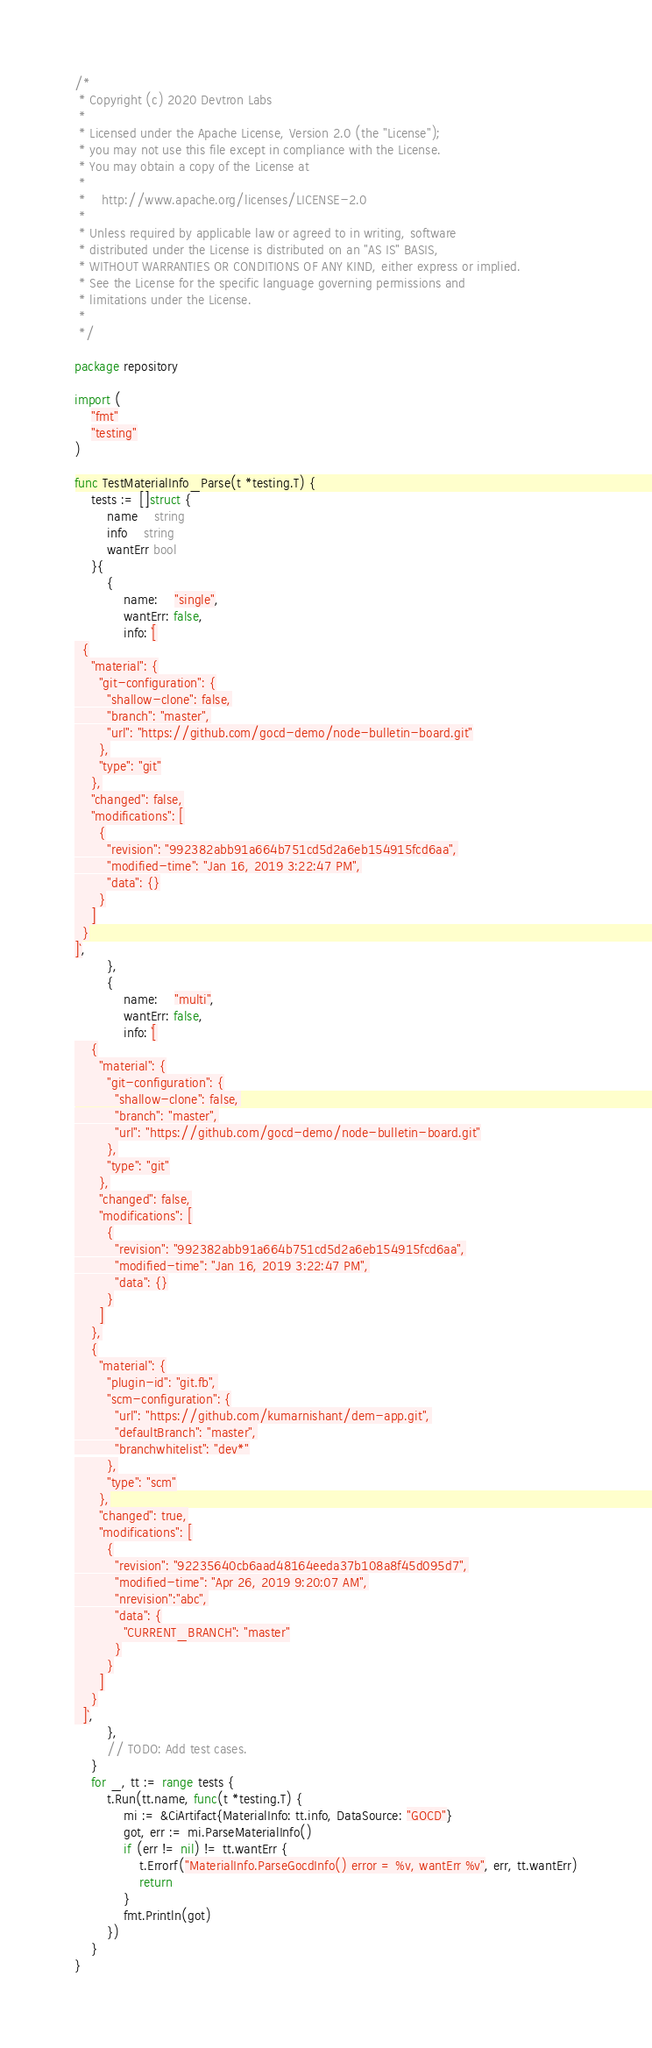<code> <loc_0><loc_0><loc_500><loc_500><_Go_>/*
 * Copyright (c) 2020 Devtron Labs
 *
 * Licensed under the Apache License, Version 2.0 (the "License");
 * you may not use this file except in compliance with the License.
 * You may obtain a copy of the License at
 *
 *    http://www.apache.org/licenses/LICENSE-2.0
 *
 * Unless required by applicable law or agreed to in writing, software
 * distributed under the License is distributed on an "AS IS" BASIS,
 * WITHOUT WARRANTIES OR CONDITIONS OF ANY KIND, either express or implied.
 * See the License for the specific language governing permissions and
 * limitations under the License.
 *
 */

package repository

import (
	"fmt"
	"testing"
)

func TestMaterialInfo_Parse(t *testing.T) {
	tests := []struct {
		name    string
		info    string
		wantErr bool
	}{
		{
			name:    "single",
			wantErr: false,
			info: `[
  {
    "material": {
      "git-configuration": {
        "shallow-clone": false,
        "branch": "master",
        "url": "https://github.com/gocd-demo/node-bulletin-board.git"
      },
      "type": "git"
    },
    "changed": false,
    "modifications": [
      {
        "revision": "992382abb91a664b751cd5d2a6eb154915fcd6aa",
        "modified-time": "Jan 16, 2019 3:22:47 PM",
        "data": {}
      }
    ]
  }
]`,
		},
		{
			name:    "multi",
			wantErr: false,
			info: `[
    {
      "material": {
        "git-configuration": {
          "shallow-clone": false,
          "branch": "master",
          "url": "https://github.com/gocd-demo/node-bulletin-board.git"
        },
        "type": "git"
      },
      "changed": false,
      "modifications": [
        {
          "revision": "992382abb91a664b751cd5d2a6eb154915fcd6aa",
          "modified-time": "Jan 16, 2019 3:22:47 PM",
          "data": {}
        }
      ]
    },
    {
      "material": {
        "plugin-id": "git.fb",
        "scm-configuration": {
          "url": "https://github.com/kumarnishant/dem-app.git",
          "defaultBranch": "master",
          "branchwhitelist": "dev*"
        },
        "type": "scm"
      },
      "changed": true,
      "modifications": [
        {
          "revision": "92235640cb6aad48164eeda37b108a8f45d095d7",
          "modified-time": "Apr 26, 2019 9:20:07 AM",
          "nrevision":"abc",
          "data": {
            "CURRENT_BRANCH": "master"
          }
        }
      ]
    }
  ]`,
		},
		// TODO: Add test cases.
	}
	for _, tt := range tests {
		t.Run(tt.name, func(t *testing.T) {
			mi := &CiArtifact{MaterialInfo: tt.info, DataSource: "GOCD"}
			got, err := mi.ParseMaterialInfo()
			if (err != nil) != tt.wantErr {
				t.Errorf("MaterialInfo.ParseGocdInfo() error = %v, wantErr %v", err, tt.wantErr)
				return
			}
			fmt.Println(got)
		})
	}
}
</code> 